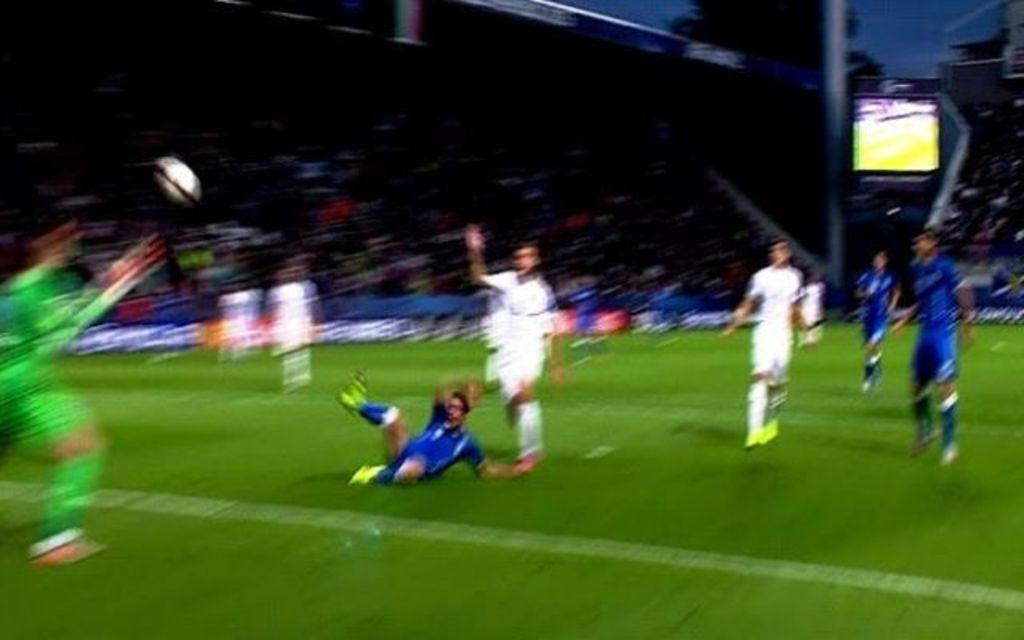What are the people in the image doing? The people in the image are playing on the ground. What object is involved in their play? There is a ball present in the image. What can be seen in the background of the image? In the background, there is a crowd, a pole, a screen, hoardings, trees, and the sky. What scent can be detected in the image? There is no mention of any scent in the image, so it cannot be determined from the image. 